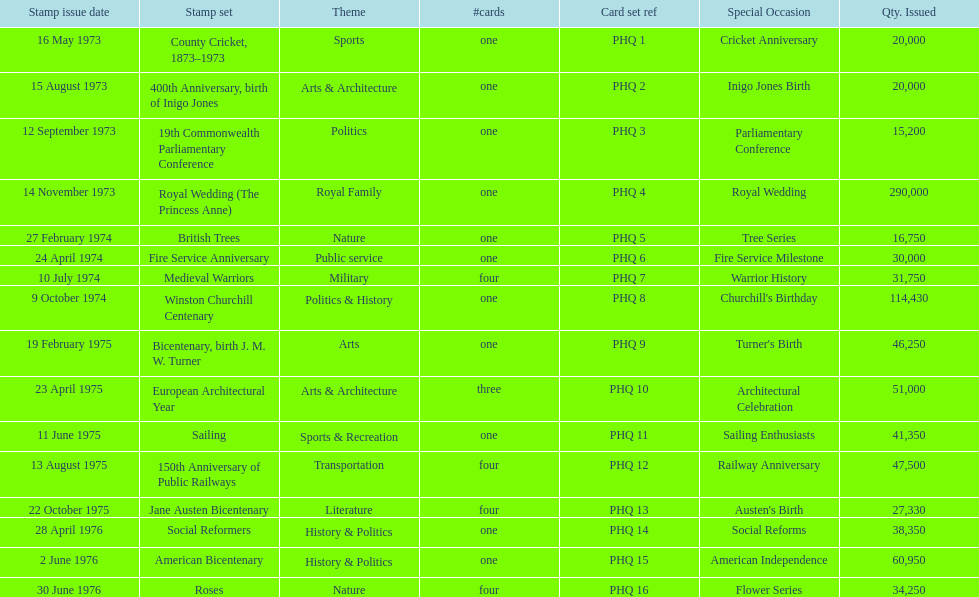Which card has the greatest number of issuances? Royal Wedding (The Princess Anne). 